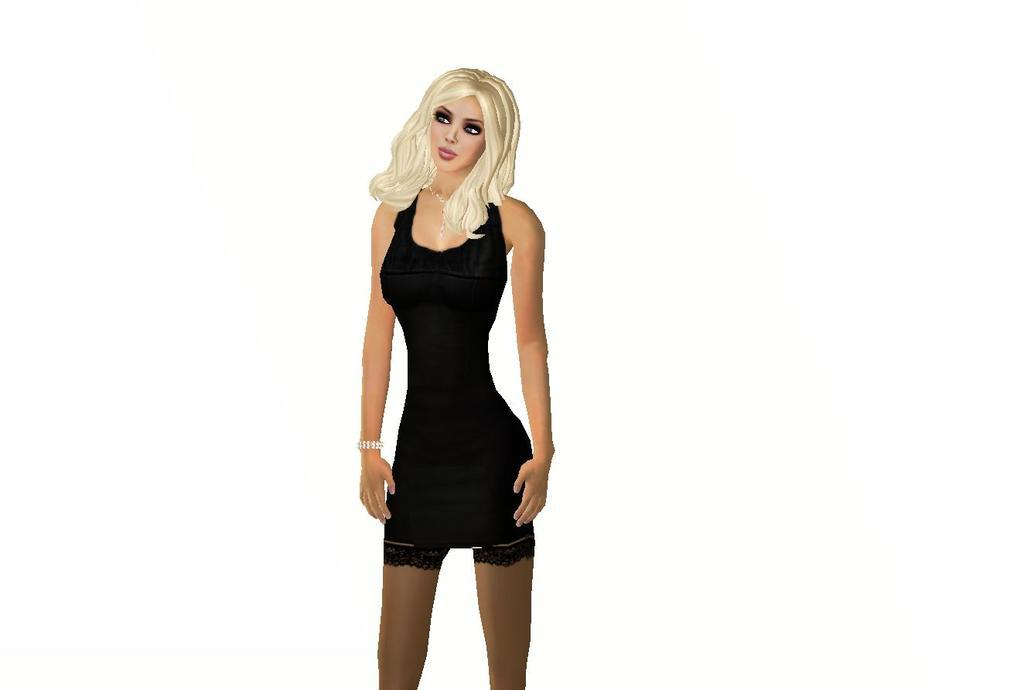What is the main subject of the picture? The main subject of the picture is an animated image of a girl. What color is the background of the image? The background of the image is white. How many babies are holding clover in the image? There are no babies or clover present in the image; it features an animated girl with a white background. 